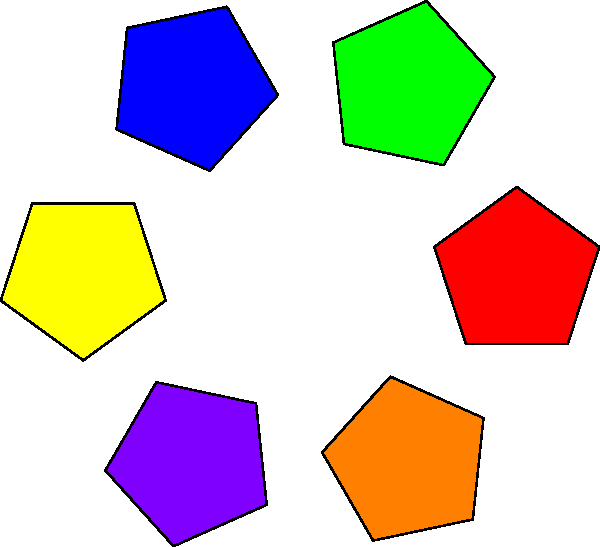In the kaleidoscopic image above, a regular pentagon is rotated and replicated around a central point. If the angle between each successive rotation is $60^\circ$, how many complete rotations are needed to return the pentagon to its original orientation? To solve this problem, we need to consider the rotational symmetry of both the overall pattern and the individual shape:

1. The kaleidoscopic pattern has 6-fold rotational symmetry (rotations of $60^\circ$).
2. A regular pentagon has 5-fold rotational symmetry (rotations of $72^\circ$).

To find when the pentagon returns to its original orientation:

3. Calculate the Least Common Multiple (LCM) of 6 and 5:
   LCM(6, 5) = 30

4. The number of rotations needed is:
   30 ÷ 6 = 5 complete rotations

5. Verify: 
   $5 \times 60^\circ = 300^\circ$
   $300^\circ \div 72^\circ = 4\frac{1}{6}$ rotations of the pentagon

6. After 5 complete rotations of the pattern, the pentagon will have rotated $4\frac{1}{6}$ times, returning to its original orientation.
Answer: 5 rotations 